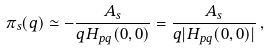Convert formula to latex. <formula><loc_0><loc_0><loc_500><loc_500>\pi _ { s } ( q ) \simeq - \frac { A _ { s } } { q H _ { p q } ( 0 , 0 ) } = \frac { A _ { s } } { q | H _ { p q } ( 0 , 0 ) | } \, ,</formula> 